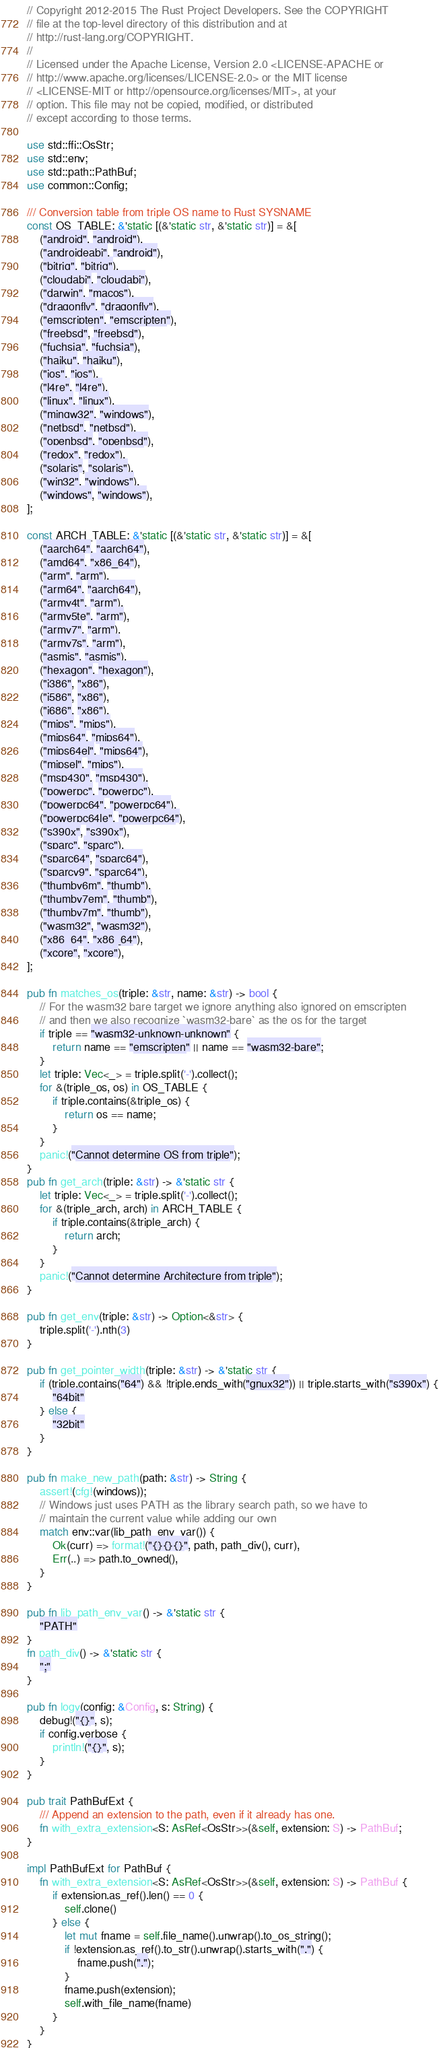<code> <loc_0><loc_0><loc_500><loc_500><_Rust_>// Copyright 2012-2015 The Rust Project Developers. See the COPYRIGHT
// file at the top-level directory of this distribution and at
// http://rust-lang.org/COPYRIGHT.
//
// Licensed under the Apache License, Version 2.0 <LICENSE-APACHE or
// http://www.apache.org/licenses/LICENSE-2.0> or the MIT license
// <LICENSE-MIT or http://opensource.org/licenses/MIT>, at your
// option. This file may not be copied, modified, or distributed
// except according to those terms.

use std::ffi::OsStr;
use std::env;
use std::path::PathBuf;
use common::Config;

/// Conversion table from triple OS name to Rust SYSNAME
const OS_TABLE: &'static [(&'static str, &'static str)] = &[
    ("android", "android"),
    ("androideabi", "android"),
    ("bitrig", "bitrig"),
    ("cloudabi", "cloudabi"),
    ("darwin", "macos"),
    ("dragonfly", "dragonfly"),
    ("emscripten", "emscripten"),
    ("freebsd", "freebsd"),
    ("fuchsia", "fuchsia"),
    ("haiku", "haiku"),
    ("ios", "ios"),
    ("l4re", "l4re"),
    ("linux", "linux"),
    ("mingw32", "windows"),
    ("netbsd", "netbsd"),
    ("openbsd", "openbsd"),
    ("redox", "redox"),
    ("solaris", "solaris"),
    ("win32", "windows"),
    ("windows", "windows"),
];

const ARCH_TABLE: &'static [(&'static str, &'static str)] = &[
    ("aarch64", "aarch64"),
    ("amd64", "x86_64"),
    ("arm", "arm"),
    ("arm64", "aarch64"),
    ("armv4t", "arm"),
    ("armv5te", "arm"),
    ("armv7", "arm"),
    ("armv7s", "arm"),
    ("asmjs", "asmjs"),
    ("hexagon", "hexagon"),
    ("i386", "x86"),
    ("i586", "x86"),
    ("i686", "x86"),
    ("mips", "mips"),
    ("mips64", "mips64"),
    ("mips64el", "mips64"),
    ("mipsel", "mips"),
    ("msp430", "msp430"),
    ("powerpc", "powerpc"),
    ("powerpc64", "powerpc64"),
    ("powerpc64le", "powerpc64"),
    ("s390x", "s390x"),
    ("sparc", "sparc"),
    ("sparc64", "sparc64"),
    ("sparcv9", "sparc64"),
    ("thumbv6m", "thumb"),
    ("thumbv7em", "thumb"),
    ("thumbv7m", "thumb"),
    ("wasm32", "wasm32"),
    ("x86_64", "x86_64"),
    ("xcore", "xcore"),
];

pub fn matches_os(triple: &str, name: &str) -> bool {
    // For the wasm32 bare target we ignore anything also ignored on emscripten
    // and then we also recognize `wasm32-bare` as the os for the target
    if triple == "wasm32-unknown-unknown" {
        return name == "emscripten" || name == "wasm32-bare";
    }
    let triple: Vec<_> = triple.split('-').collect();
    for &(triple_os, os) in OS_TABLE {
        if triple.contains(&triple_os) {
            return os == name;
        }
    }
    panic!("Cannot determine OS from triple");
}
pub fn get_arch(triple: &str) -> &'static str {
    let triple: Vec<_> = triple.split('-').collect();
    for &(triple_arch, arch) in ARCH_TABLE {
        if triple.contains(&triple_arch) {
            return arch;
        }
    }
    panic!("Cannot determine Architecture from triple");
}

pub fn get_env(triple: &str) -> Option<&str> {
    triple.split('-').nth(3)
}

pub fn get_pointer_width(triple: &str) -> &'static str {
    if (triple.contains("64") && !triple.ends_with("gnux32")) || triple.starts_with("s390x") {
        "64bit"
    } else {
        "32bit"
    }
}

pub fn make_new_path(path: &str) -> String {
    assert!(cfg!(windows));
    // Windows just uses PATH as the library search path, so we have to
    // maintain the current value while adding our own
    match env::var(lib_path_env_var()) {
        Ok(curr) => format!("{}{}{}", path, path_div(), curr),
        Err(..) => path.to_owned(),
    }
}

pub fn lib_path_env_var() -> &'static str {
    "PATH"
}
fn path_div() -> &'static str {
    ";"
}

pub fn logv(config: &Config, s: String) {
    debug!("{}", s);
    if config.verbose {
        println!("{}", s);
    }
}

pub trait PathBufExt {
    /// Append an extension to the path, even if it already has one.
    fn with_extra_extension<S: AsRef<OsStr>>(&self, extension: S) -> PathBuf;
}

impl PathBufExt for PathBuf {
    fn with_extra_extension<S: AsRef<OsStr>>(&self, extension: S) -> PathBuf {
        if extension.as_ref().len() == 0 {
            self.clone()
        } else {
            let mut fname = self.file_name().unwrap().to_os_string();
            if !extension.as_ref().to_str().unwrap().starts_with(".") {
                fname.push(".");
            }
            fname.push(extension);
            self.with_file_name(fname)
        }
    }
}
</code> 